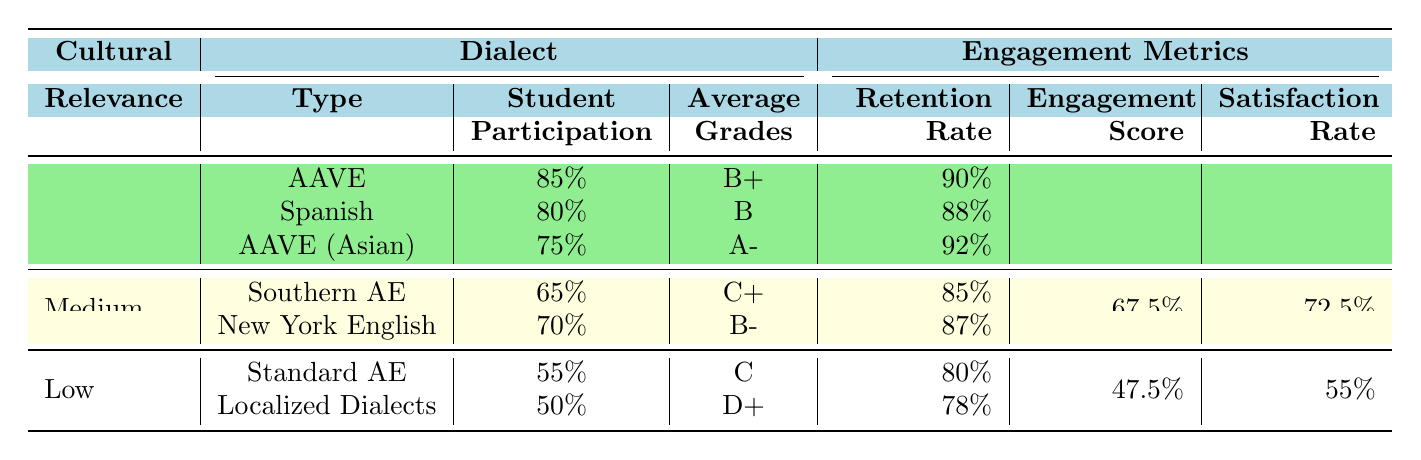What is the student participation percentage for African American Vernacular English? In the table under the "High" cultural relevance and "AAVE" dialect section, the student participation percentage is listed as 85%.
Answer: 85% What is the average grade for students using the Spanish dialect? The average grades for students using the Spanish dialect is listed as B under the "High" cultural relevance section.
Answer: B Which dialect has the highest retention rate? Among the dialects listed, African American Vernacular English has the highest retention rate of 90%.
Answer: African American Vernacular English What is the engagement score for Regional History? The engagement score for Regional History, found in the "Medium" cultural relevance section, is 70%.
Answer: 70% What is the retention rate for Localized Dialects? In the "Low" cultural relevance category, Localized Dialects have a retention rate of 78%.
Answer: 78% Calculate the average engagement score for all dialects under High cultural relevance. The engagement scores for AAVE, Spanish, and Asian AAVE are grouped under High relevance. They are 90%, 85%, and 88%. The average engagement score is (90 + 85 + 88) / 3 = 87.67%.
Answer: 87.67% Is the average grade for Southern American English higher than the average grade for Standard American English? The average grade for Southern American English is C+ while Standard American English has average grades of C. Therefore, C+ is higher than C.
Answer: Yes What is the satisfaction rate for Generic Textbooks? The satisfaction rate for Generic Textbooks, found in the "Low" cultural relevance section, is 50%.
Answer: 50% What is the difference in student participation percentage between AAVE and Southern American English? AAVE has a student participation percentage of 85% while Southern American English has 65%. The difference is 85% - 65% = 20%.
Answer: 20% Which dialect has the lowest engagement score among the listed dialects? The engagement score for Generic Textbooks under Low cultural relevance is 45%, which is the lowest engagement score compared to others.
Answer: Generic Textbooks 